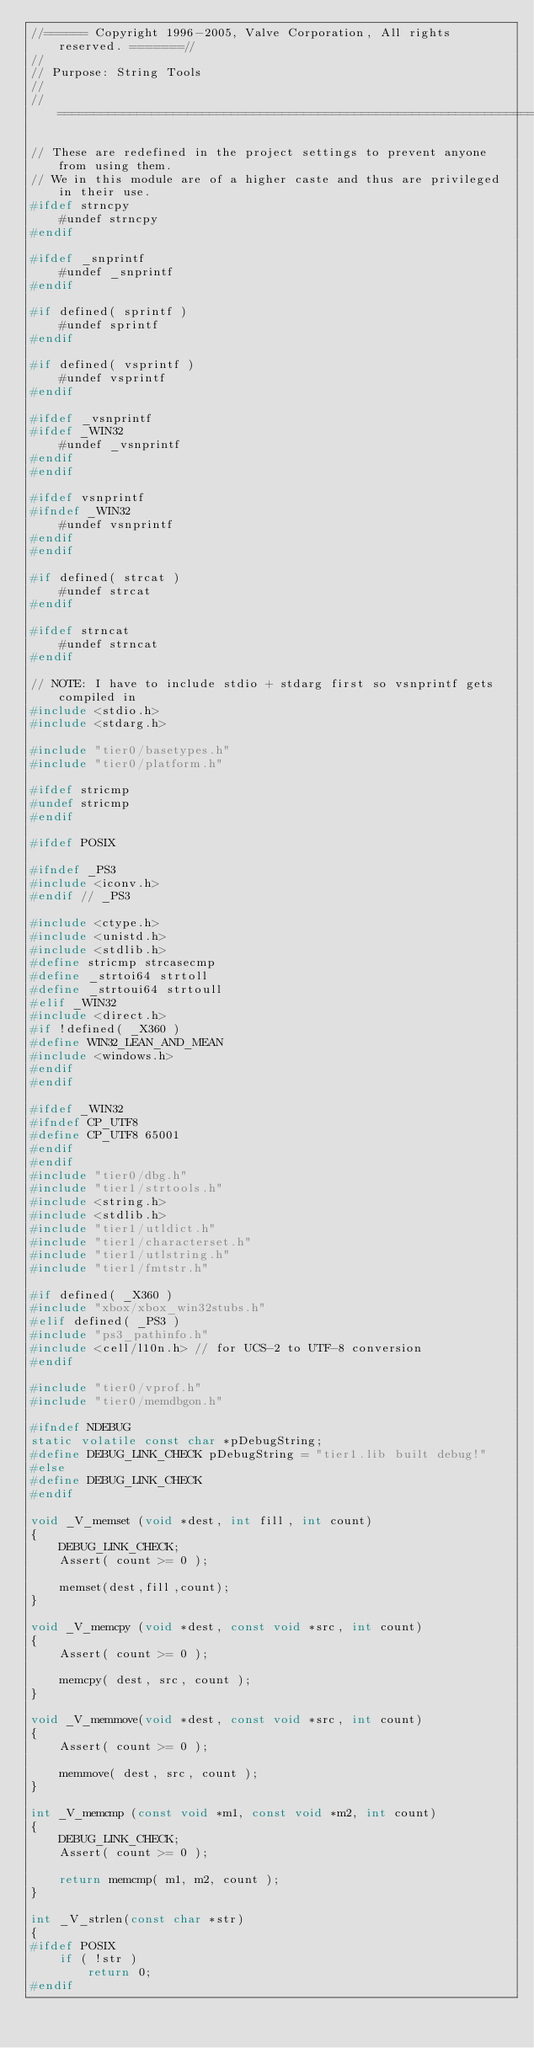Convert code to text. <code><loc_0><loc_0><loc_500><loc_500><_C++_>//====== Copyright 1996-2005, Valve Corporation, All rights reserved. =======//
//
// Purpose: String Tools
//
//===========================================================================//

// These are redefined in the project settings to prevent anyone from using them.
// We in this module are of a higher caste and thus are privileged in their use.
#ifdef strncpy
	#undef strncpy
#endif

#ifdef _snprintf
	#undef _snprintf
#endif

#if defined( sprintf )
	#undef sprintf
#endif

#if defined( vsprintf )
	#undef vsprintf
#endif

#ifdef _vsnprintf
#ifdef _WIN32
	#undef _vsnprintf
#endif
#endif

#ifdef vsnprintf
#ifndef _WIN32
	#undef vsnprintf
#endif
#endif

#if defined( strcat )
	#undef strcat
#endif

#ifdef strncat
	#undef strncat
#endif

// NOTE: I have to include stdio + stdarg first so vsnprintf gets compiled in
#include <stdio.h>
#include <stdarg.h>

#include "tier0/basetypes.h"
#include "tier0/platform.h"

#ifdef stricmp
#undef stricmp
#endif

#ifdef POSIX

#ifndef _PS3
#include <iconv.h>
#endif // _PS3

#include <ctype.h>
#include <unistd.h>
#include <stdlib.h>
#define stricmp strcasecmp
#define _strtoi64 strtoll
#define _strtoui64 strtoull
#elif _WIN32
#include <direct.h>
#if !defined( _X360 )
#define WIN32_LEAN_AND_MEAN
#include <windows.h>
#endif
#endif

#ifdef _WIN32
#ifndef CP_UTF8
#define CP_UTF8 65001
#endif
#endif
#include "tier0/dbg.h"
#include "tier1/strtools.h"
#include <string.h>
#include <stdlib.h>
#include "tier1/utldict.h"
#include "tier1/characterset.h"
#include "tier1/utlstring.h"
#include "tier1/fmtstr.h"

#if defined( _X360 )
#include "xbox/xbox_win32stubs.h"
#elif defined( _PS3 )
#include "ps3_pathinfo.h"
#include <cell/l10n.h> // for UCS-2 to UTF-8 conversion
#endif

#include "tier0/vprof.h"
#include "tier0/memdbgon.h"

#ifndef NDEBUG
static volatile const char *pDebugString;
#define DEBUG_LINK_CHECK pDebugString = "tier1.lib built debug!"
#else
#define DEBUG_LINK_CHECK
#endif

void _V_memset (void *dest, int fill, int count)
{
	DEBUG_LINK_CHECK;
	Assert( count >= 0 );

	memset(dest,fill,count);
}

void _V_memcpy (void *dest, const void *src, int count)
{
	Assert( count >= 0 );

	memcpy( dest, src, count );
}

void _V_memmove(void *dest, const void *src, int count)
{
	Assert( count >= 0 );

	memmove( dest, src, count );
}

int _V_memcmp (const void *m1, const void *m2, int count)
{
	DEBUG_LINK_CHECK;
	Assert( count >= 0 );

	return memcmp( m1, m2, count );
}

int	_V_strlen(const char *str)
{
#ifdef POSIX
	if ( !str )
		return 0;
#endif</code> 